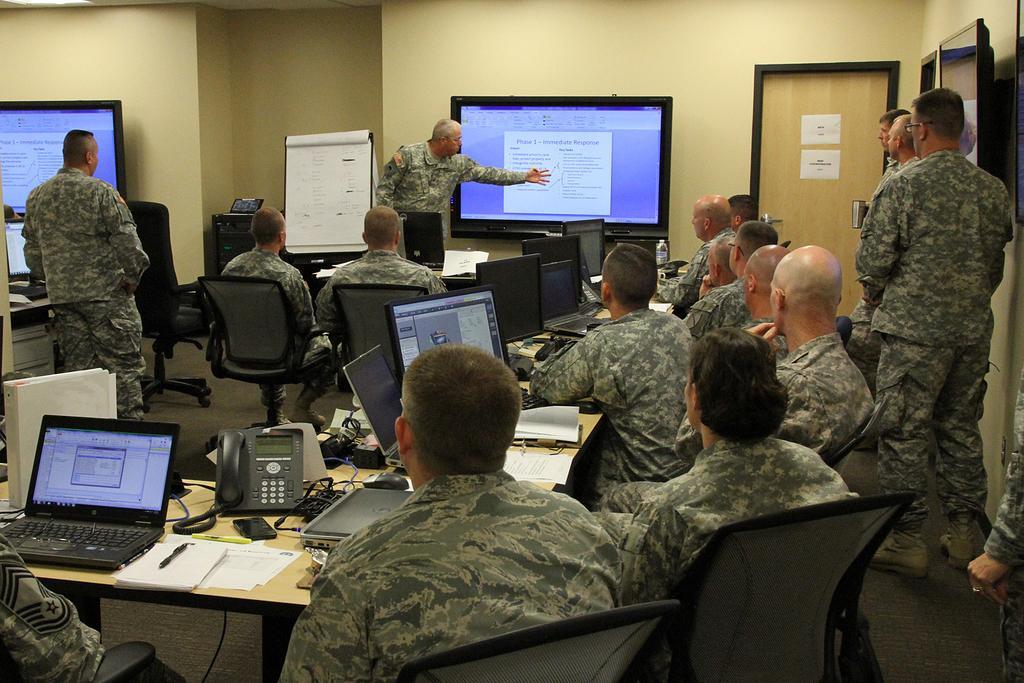In one or two sentences, can you explain what this image depicts? In this image we can see men standing and sitting and watching the projector display in a room. 